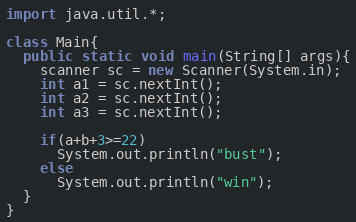<code> <loc_0><loc_0><loc_500><loc_500><_Java_>import java.util.*;

class Main{
  public static void main(String[] args){
    scanner sc = new Scanner(System.in);
    int a1 = sc.nextInt();
    int a2 = sc.nextInt();
    int a3 = sc.nextInt();

    if(a+b+3>=22)
      System.out.println("bust");
    else
      System.out.println("win");
  }
}
</code> 